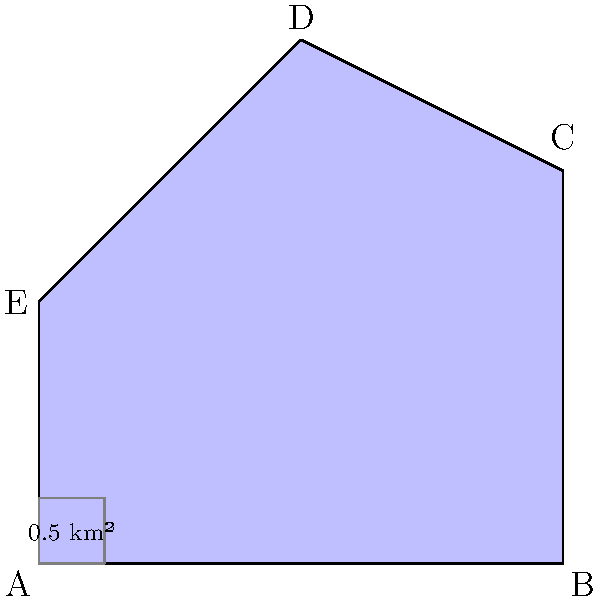A map shows the irregular area affected by a recent flood. The shape is roughly represented by the polygon ABCDE, where each grid square represents 0.5 km². Estimate the total area affected by the flood using the method of counting squares. Round your answer to the nearest whole number. To estimate the area of the irregular shape, we'll use the method of counting squares:

1. Count the full squares within the shape: There are approximately 8 full squares.

2. Estimate partial squares:
   - Along AB: About 1.5 squares
   - Along BC: About 1 square
   - Along CD: About 1 square
   - Along DE: About 1.5 squares
   - Along EA: About 1 square

3. Sum up the squares:
   Full squares + Partial squares = 8 + 6 = 14 squares

4. Calculate the area:
   Each square represents 0.5 km²
   Total area = 14 * 0.5 km² = 7 km²

5. Round to the nearest whole number:
   7 km² (already a whole number)

Therefore, the estimated area affected by the flood is approximately 7 km².
Answer: 7 km² 